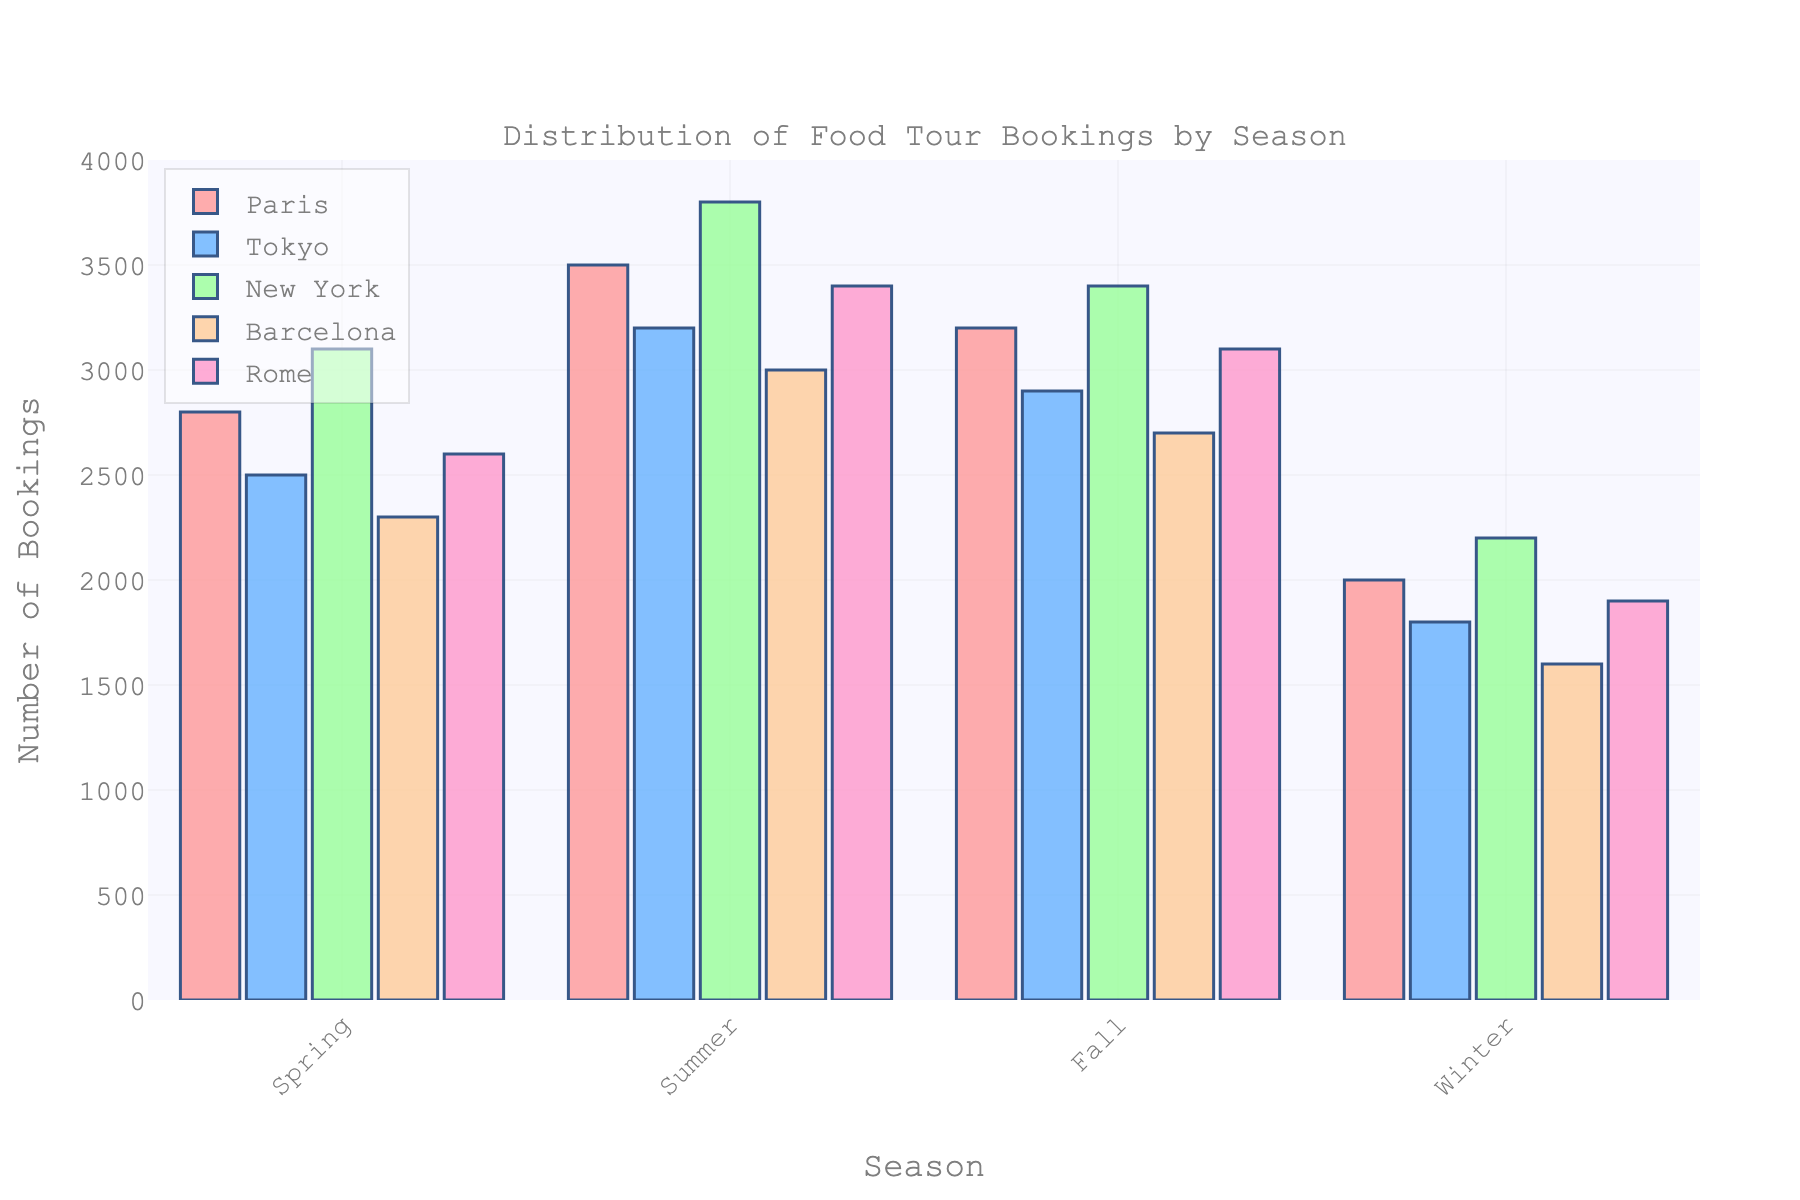Which season has the highest number of food tour bookings in Tokyo? Look at the bar representing Tokyo for each season. The highest bar indicates the season with the maximum number of bookings. The summer season shows the highest bar for Tokyo.
Answer: Summer What is the total number of food tour bookings for New York across all seasons? Sum the bookings for New York in each season: Spring (3100) + Summer (3800) + Fall (3400) + Winter (2200).
Answer: 12500 Compare the number of bookings in Spring and Winter for Rome. Which season has more bookings and by how much? Look at the bars for Rome in both Spring and Winter. Subtract the lower number (1900 in Winter) from the higher number (2600 in Spring).
Answer: Spring by 700 Which city has the lowest number of food tour bookings in Winter? Identify the lowest bar among Tokyo, Paris, New York, Barcelona, and Rome for Winter. The bar for Barcelona is the lowest.
Answer: Barcelona What is the average number of bookings across all cities in Summer? Sum the number of bookings for all cities in Summer and divide by the number of cities: (3500 + 3200 + 3800 + 3000 + 3400) / 5.
Answer: 3380 Which season has the most evenly distributed bookings across the five cities? Examine the bars' heights within each season to identify the season with the most similar heights. Fall has the most evenly distributed bookings.
Answer: Fall By how much do food tour bookings in Summer for Paris exceed those in Winter for Rome? Subtract the number of bookings for Winter in Rome (1900) from the number of bookings in Summer for Paris (3500).
Answer: 1600 Are there any seasons where Tokyo and Barcelona have the same number of bookings? Compare the bars for Tokyo and Barcelona across all seasons. None of the bars are at the same height.
Answer: No How do the Spring bookings compare between Paris and New York? Compare the bars for Spring for Paris (2800) and New York (3100). New York has 300 more bookings than Paris.
Answer: New York has 300 more bookings What is the percentage increase in bookings from Winter to Summer for Barcelona? Subtract Winter bookings (1600) from Summer bookings (3000). Divide by Winter bookings and multiply by 100: ((3000 - 1600) / 1600) * 100.
Answer: 87.5% 